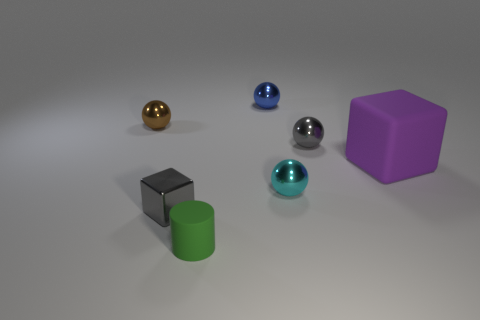The matte object left of the gray ball has what shape?
Offer a very short reply. Cylinder. What color is the cylinder?
Make the answer very short. Green. What is the shape of the brown thing that is the same material as the cyan thing?
Your answer should be compact. Sphere. There is a cube in front of the rubber block; is its size the same as the tiny blue thing?
Your answer should be very brief. Yes. What number of things are gray objects in front of the big purple object or tiny things behind the cyan ball?
Keep it short and to the point. 4. Does the object that is left of the shiny block have the same color as the small metal block?
Give a very brief answer. No. How many metal things are either big green cylinders or gray things?
Make the answer very short. 2. The large object has what shape?
Your answer should be compact. Cube. Is there any other thing that has the same material as the blue sphere?
Give a very brief answer. Yes. Is the material of the big object the same as the cyan object?
Your response must be concise. No. 